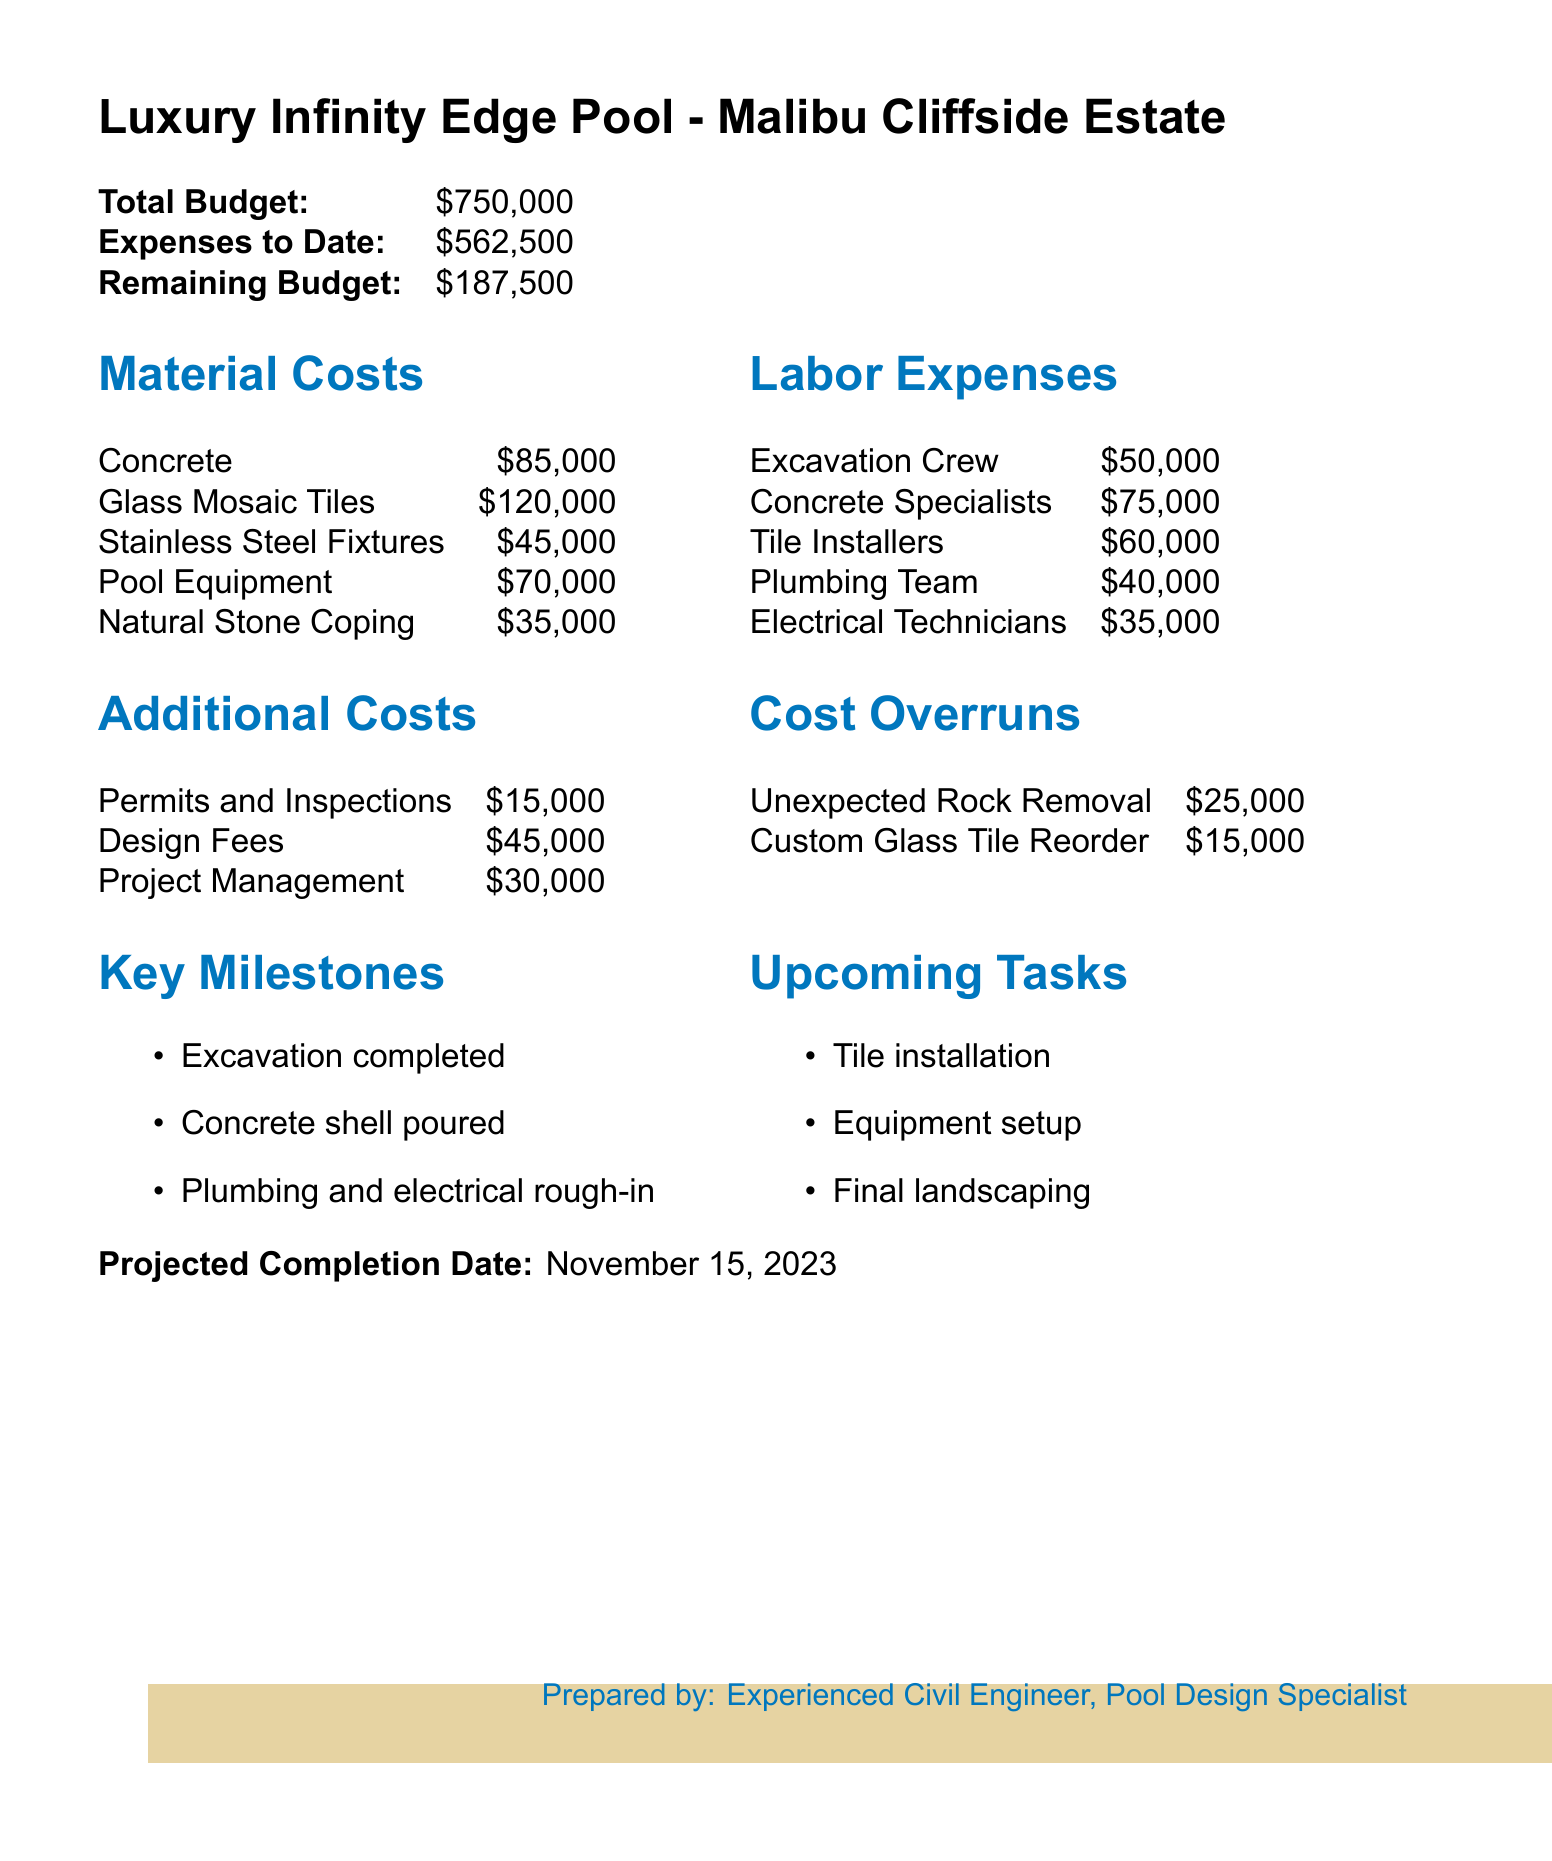What is the total budget? The total budget is explicitly stated in the document, which lists the total budget for the project.
Answer: $750,000 How much has been spent to date? The document specifies the expenses to date, detailing how much has been utilized from the total budget.
Answer: $562,500 What is the remaining budget? The remaining budget is provided in the report and shows how much is left after expenses have been deducted from the total budget.
Answer: $187,500 What is the cost of glass mosaic tiles? The document contains a section that breaks down material costs, including the specific cost of glass mosaic tiles.
Answer: $120,000 What are the upcoming tasks? The report lists the upcoming tasks relevant to the project, indicating the next steps in the construction of the pool.
Answer: Tile installation, Equipment setup, Final landscaping What are the total labor expenses? This question requires summing up the individual labor expenses listed to find the total labor costs for the project.
Answer: $300,000 What is the projected completion date? The document provides a date that indicates when the luxury swimming pool project is expected to be completed.
Answer: November 15, 2023 What is the cost of unexpected rock removal? The document details the cost overruns, specifically identifying how much was allocated for unexpected rock removal.
Answer: $25,000 What key milestone was recently completed? The report includes a section on key milestones, showing the progress made so far in the project.
Answer: Excavation completed 